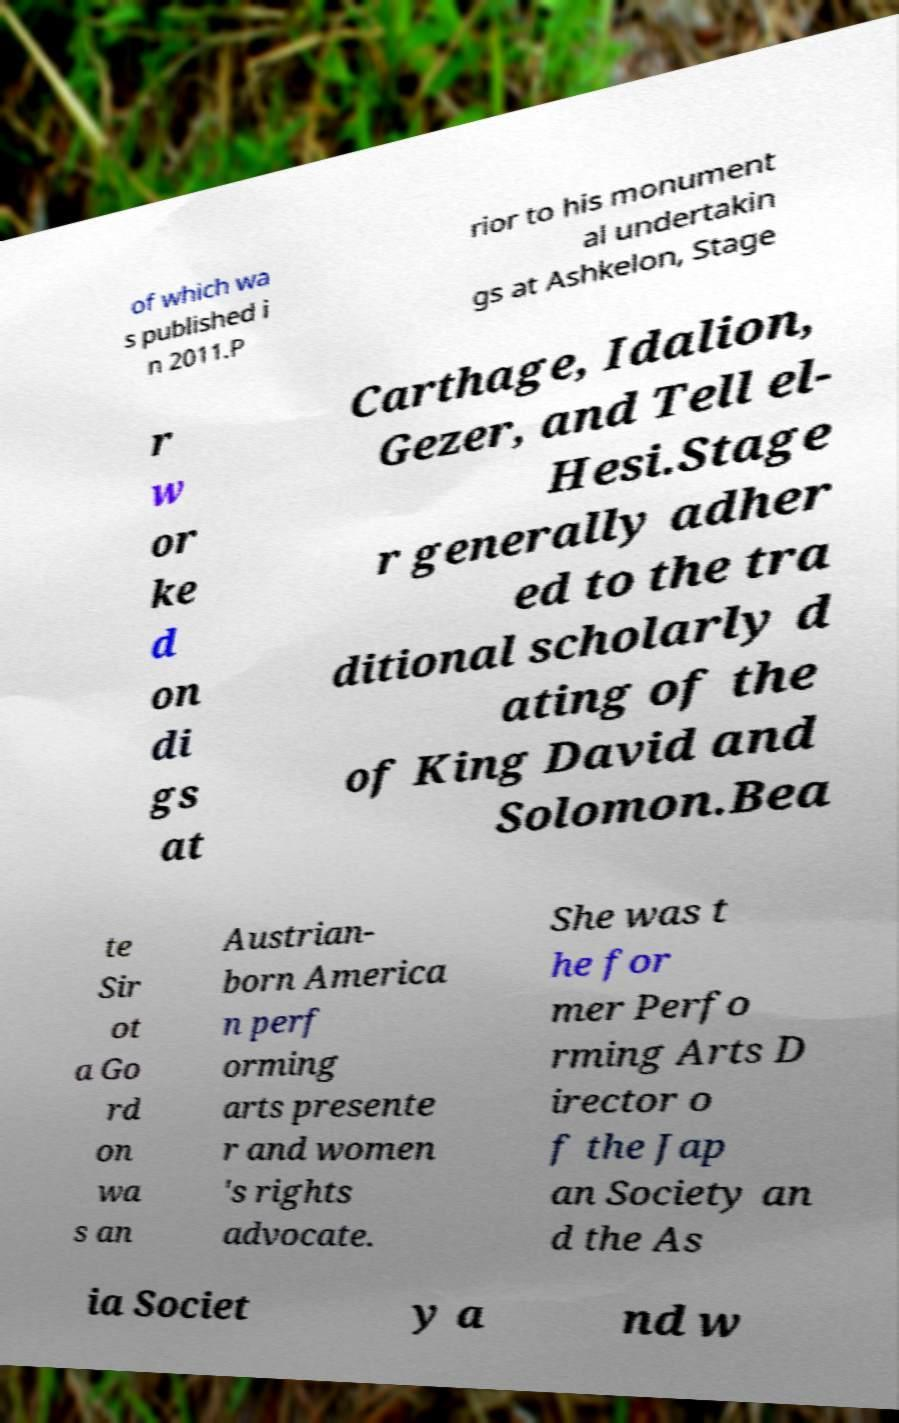For documentation purposes, I need the text within this image transcribed. Could you provide that? of which wa s published i n 2011.P rior to his monument al undertakin gs at Ashkelon, Stage r w or ke d on di gs at Carthage, Idalion, Gezer, and Tell el- Hesi.Stage r generally adher ed to the tra ditional scholarly d ating of the of King David and Solomon.Bea te Sir ot a Go rd on wa s an Austrian- born America n perf orming arts presente r and women 's rights advocate. She was t he for mer Perfo rming Arts D irector o f the Jap an Society an d the As ia Societ y a nd w 